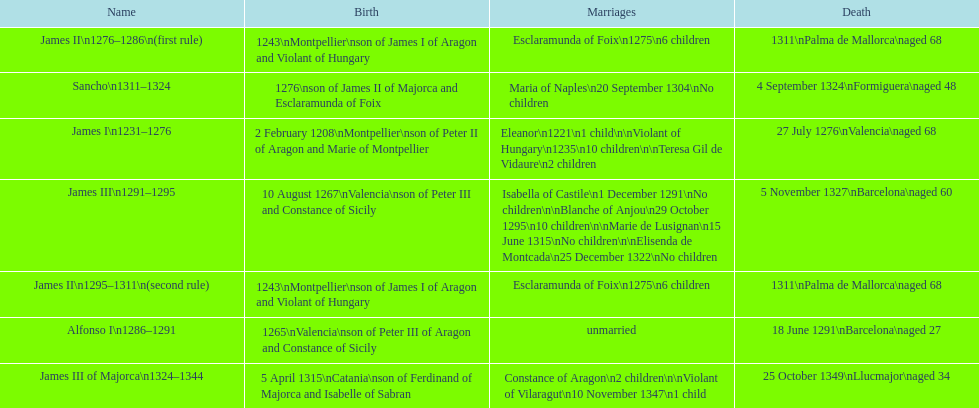How many of these monarchs died before the age of 65? 4. 